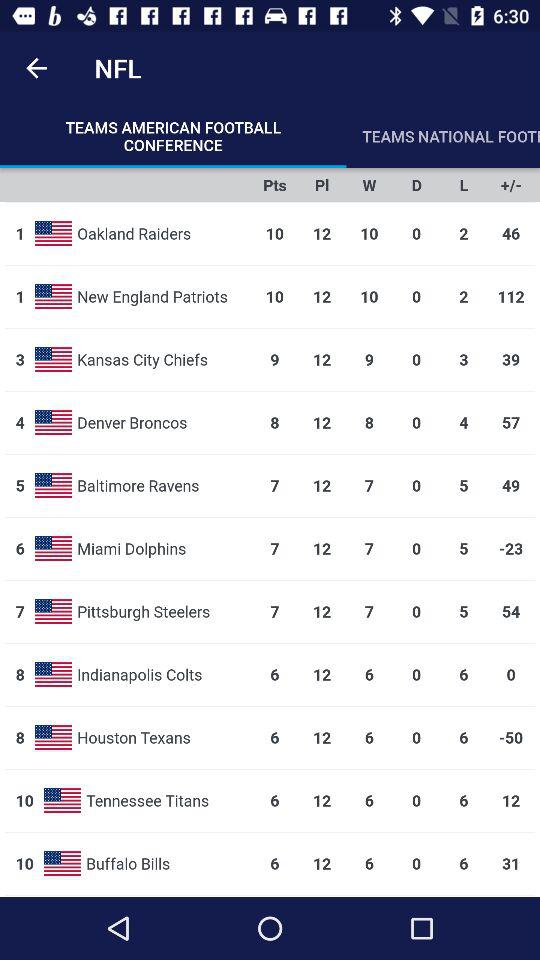What is the Buffalo Bills' PL score? The Buffalo Bills' PL score is 12. 